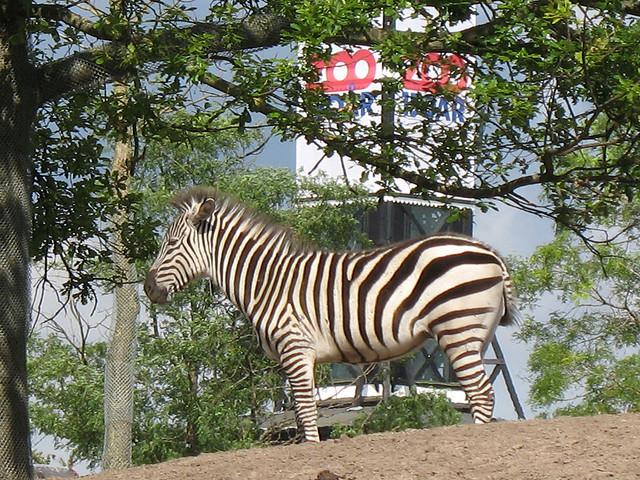How many animals are in the photo?
Concise answer only. 1. Is the zebra waiting for her mate?
Be succinct. No. How many zebras are there?
Write a very short answer. 1. Could this be in the wild?
Keep it brief. No. How many stripes?
Give a very brief answer. Many. Is this a safe habitat for a human to be in?
Short answer required. Yes. Is this zebra in the wild?
Keep it brief. No. Is the zebras head down?
Concise answer only. No. 